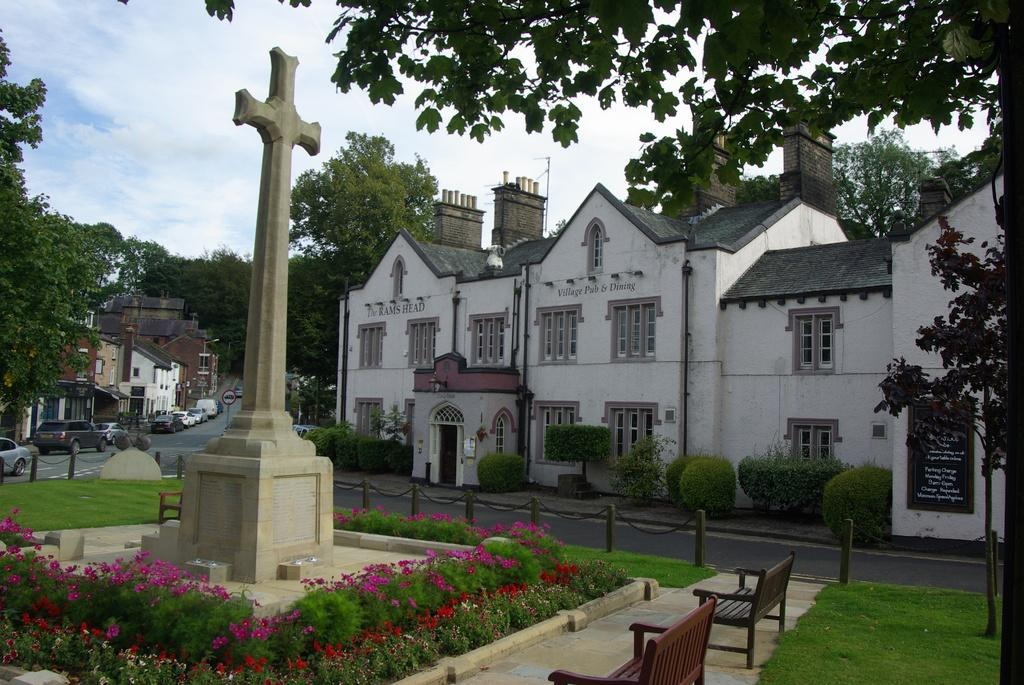What type of structures can be seen in the image? There are buildings in the image. What vehicles are parked in the image? There are cars parked in the image. What type of vegetation is present in the image? There are trees and plants with flowers in the image. What type of seating is available in the image? There are benches in the image. What is the condition of the sky in the image? The sky is blue and cloudy in the image. What type of music can be heard playing in the image? There is no indication of music being played in the image. Can you see anyone jumping in the image? There is no one jumping in the image. 